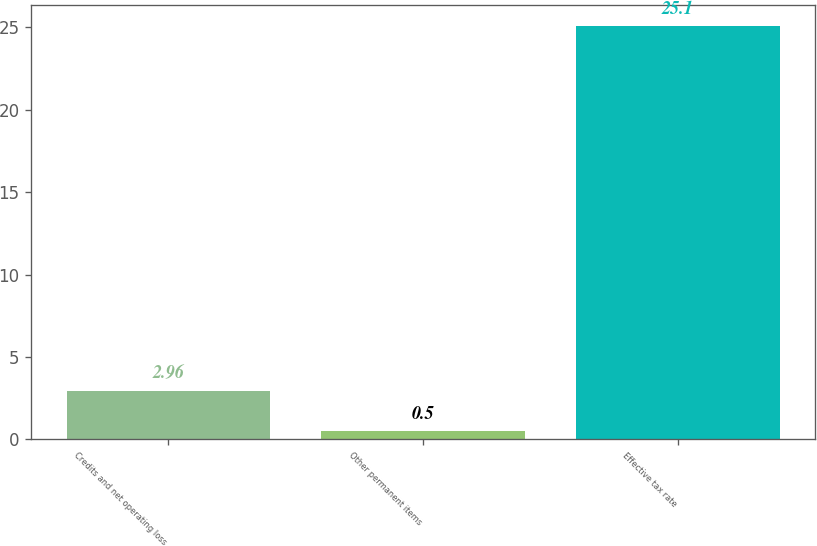<chart> <loc_0><loc_0><loc_500><loc_500><bar_chart><fcel>Credits and net operating loss<fcel>Other permanent items<fcel>Effective tax rate<nl><fcel>2.96<fcel>0.5<fcel>25.1<nl></chart> 